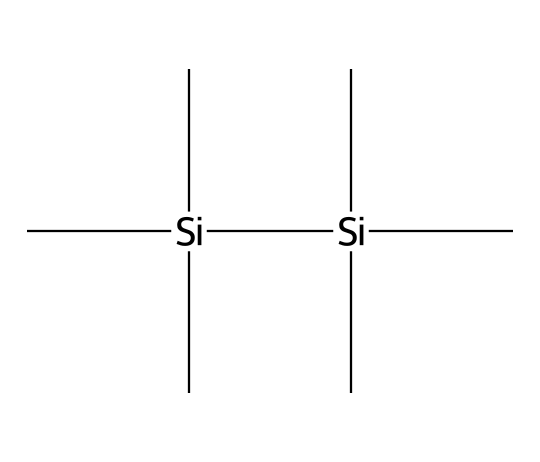What is the overall molecular formula of hexamethyldisilane? By analyzing the structure shown in the SMILES, we can count the atoms. There are two silicon (Si) atoms and six carbon (C) atoms. Each silicon is bonded to three methyl (CH3) groups contributing to a total of 12 hydrogen (H) atoms. Thus, the complete formula is C6H18Si2.
Answer: C6H18Si2 How many silicon atoms are present in hexamethyldisilane? The SMILES representation indicates that there are two silicon (Si) atoms clearly shown in the structure.
Answer: 2 What type of chemical bond connects the carbon and silicon atoms in hexamethyldisilane? In this compound, the carbon and silicon atoms are connected by sigma (σ) bonds, which are single covalent bonds formed by the overlap of atomic orbitals.
Answer: sigma What is the hybridization of the silicon atoms in hexamethyldisilane? The structure shows that each silicon atom is sp3 hybridized because they are bonded to four groups (three methyl groups and one silicon atom). This is characteristic of tetrahedral geometry.
Answer: sp3 How many bonds does each silicon atom form in hexamethyldisilane? Each silicon atom forms four single bonds: three with the carbon atoms (three methyl groups) and one with another silicon atom, making the total four bonds per silicon atom.
Answer: 4 What is a distinguishing feature of silanes, specifically regarding hexamethyldisilane? A key characteristic of silanes is the presence of Si-H bonds; however, hexamethyldisilane is fully substituted with methyl groups, lacking Si-H bonds altogether while showcasing silicon's ability to bond with carbon.
Answer: lack of Si-H bonds What is the bond angle around the silicon atoms in hexamethyldisilane? Considering that silicon is sp3 hybridized, the bond angles around each silicon atom are approximately 109.5 degrees, typical for tetrahedral geometries.
Answer: 109.5 degrees 